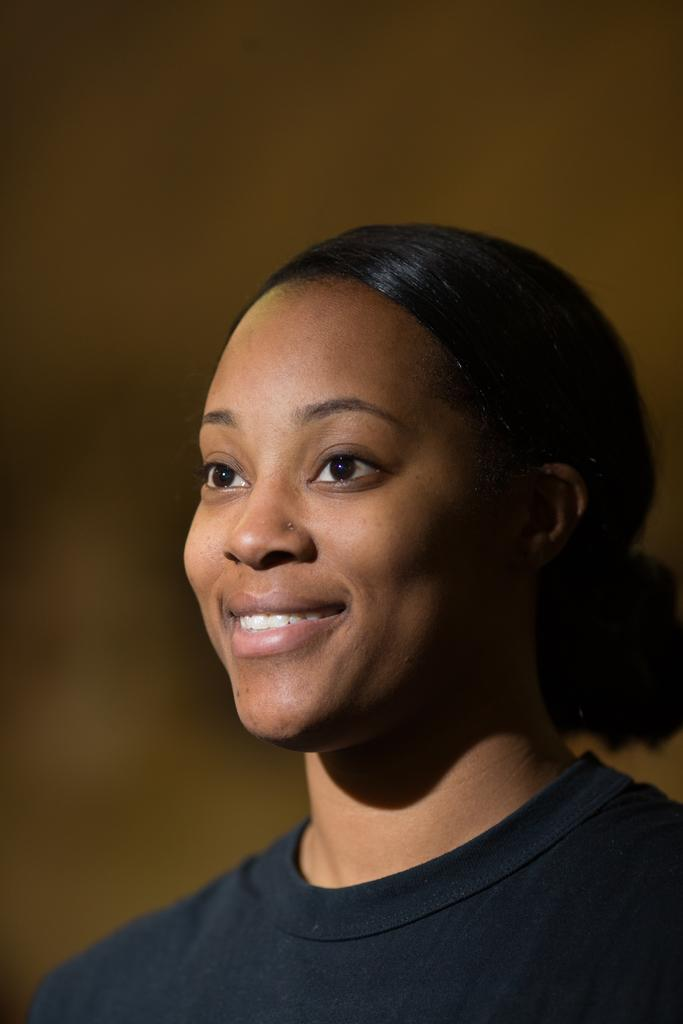Who is present in the image? There is a woman in the image. What is the woman's facial expression? The woman is smiling. Can you describe the background of the image? The background of the image is blurred. What type of insect can be seen flying near the woman's ear in the image? There is no insect present in the image. Can you tell me how many owls are perched on the woman's shoulder in the image? There are no owls present in the image. 